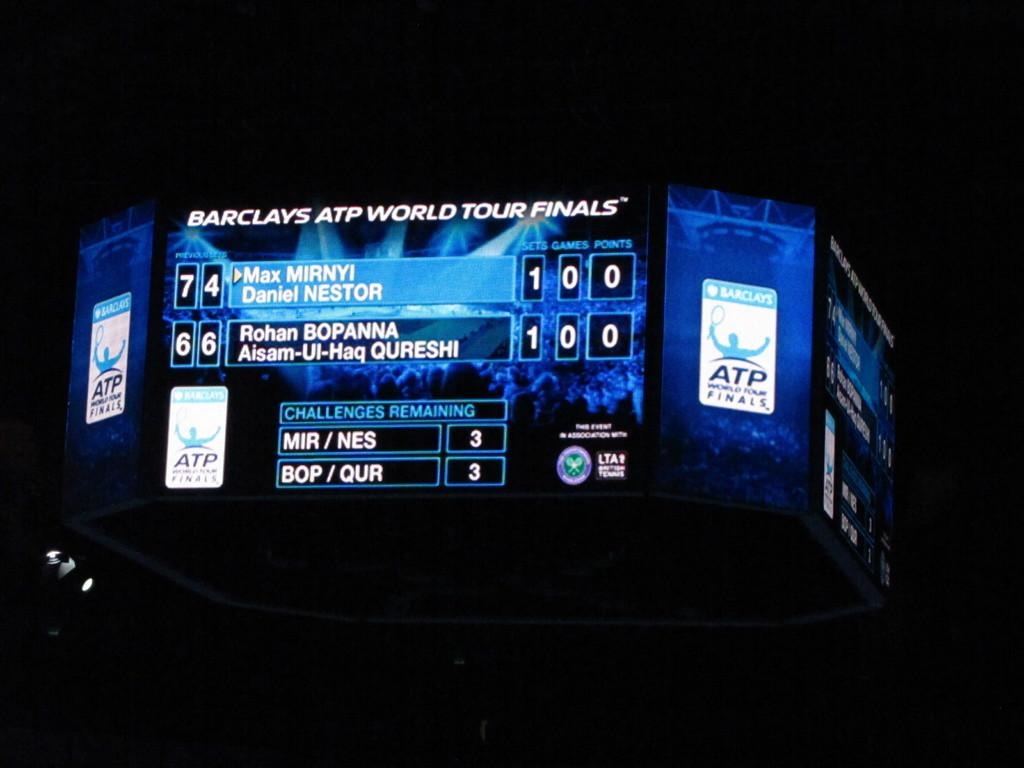<image>
Relay a brief, clear account of the picture shown. a socreboard with has the name Barclays at the top 